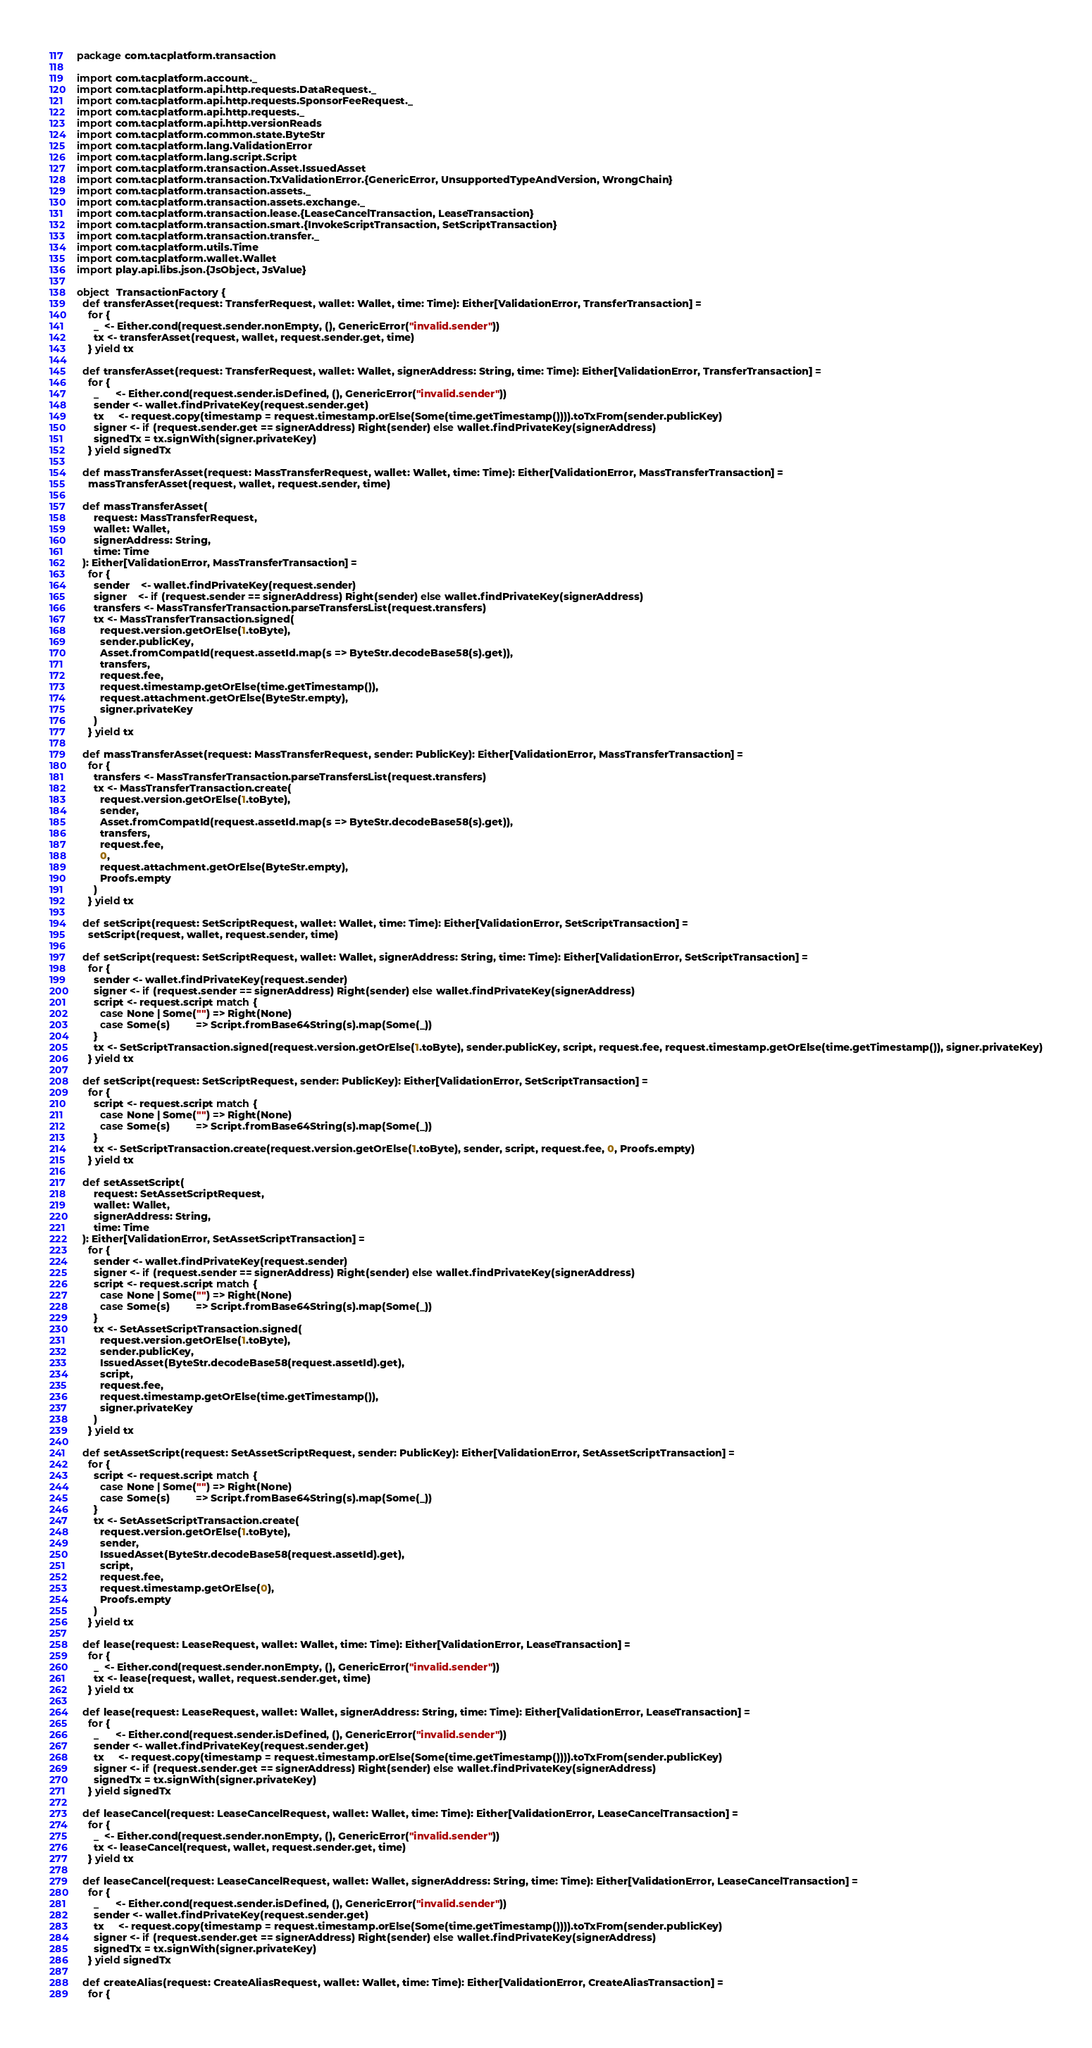Convert code to text. <code><loc_0><loc_0><loc_500><loc_500><_Scala_>package com.tacplatform.transaction

import com.tacplatform.account._
import com.tacplatform.api.http.requests.DataRequest._
import com.tacplatform.api.http.requests.SponsorFeeRequest._
import com.tacplatform.api.http.requests._
import com.tacplatform.api.http.versionReads
import com.tacplatform.common.state.ByteStr
import com.tacplatform.lang.ValidationError
import com.tacplatform.lang.script.Script
import com.tacplatform.transaction.Asset.IssuedAsset
import com.tacplatform.transaction.TxValidationError.{GenericError, UnsupportedTypeAndVersion, WrongChain}
import com.tacplatform.transaction.assets._
import com.tacplatform.transaction.assets.exchange._
import com.tacplatform.transaction.lease.{LeaseCancelTransaction, LeaseTransaction}
import com.tacplatform.transaction.smart.{InvokeScriptTransaction, SetScriptTransaction}
import com.tacplatform.transaction.transfer._
import com.tacplatform.utils.Time
import com.tacplatform.wallet.Wallet
import play.api.libs.json.{JsObject, JsValue}

object  TransactionFactory {
  def transferAsset(request: TransferRequest, wallet: Wallet, time: Time): Either[ValidationError, TransferTransaction] =
    for {
      _  <- Either.cond(request.sender.nonEmpty, (), GenericError("invalid.sender"))
      tx <- transferAsset(request, wallet, request.sender.get, time)
    } yield tx

  def transferAsset(request: TransferRequest, wallet: Wallet, signerAddress: String, time: Time): Either[ValidationError, TransferTransaction] =
    for {
      _      <- Either.cond(request.sender.isDefined, (), GenericError("invalid.sender"))
      sender <- wallet.findPrivateKey(request.sender.get)
      tx     <- request.copy(timestamp = request.timestamp.orElse(Some(time.getTimestamp()))).toTxFrom(sender.publicKey)
      signer <- if (request.sender.get == signerAddress) Right(sender) else wallet.findPrivateKey(signerAddress)
      signedTx = tx.signWith(signer.privateKey)
    } yield signedTx

  def massTransferAsset(request: MassTransferRequest, wallet: Wallet, time: Time): Either[ValidationError, MassTransferTransaction] =
    massTransferAsset(request, wallet, request.sender, time)

  def massTransferAsset(
      request: MassTransferRequest,
      wallet: Wallet,
      signerAddress: String,
      time: Time
  ): Either[ValidationError, MassTransferTransaction] =
    for {
      sender    <- wallet.findPrivateKey(request.sender)
      signer    <- if (request.sender == signerAddress) Right(sender) else wallet.findPrivateKey(signerAddress)
      transfers <- MassTransferTransaction.parseTransfersList(request.transfers)
      tx <- MassTransferTransaction.signed(
        request.version.getOrElse(1.toByte),
        sender.publicKey,
        Asset.fromCompatId(request.assetId.map(s => ByteStr.decodeBase58(s).get)),
        transfers,
        request.fee,
        request.timestamp.getOrElse(time.getTimestamp()),
        request.attachment.getOrElse(ByteStr.empty),
        signer.privateKey
      )
    } yield tx

  def massTransferAsset(request: MassTransferRequest, sender: PublicKey): Either[ValidationError, MassTransferTransaction] =
    for {
      transfers <- MassTransferTransaction.parseTransfersList(request.transfers)
      tx <- MassTransferTransaction.create(
        request.version.getOrElse(1.toByte),
        sender,
        Asset.fromCompatId(request.assetId.map(s => ByteStr.decodeBase58(s).get)),
        transfers,
        request.fee,
        0,
        request.attachment.getOrElse(ByteStr.empty),
        Proofs.empty
      )
    } yield tx

  def setScript(request: SetScriptRequest, wallet: Wallet, time: Time): Either[ValidationError, SetScriptTransaction] =
    setScript(request, wallet, request.sender, time)

  def setScript(request: SetScriptRequest, wallet: Wallet, signerAddress: String, time: Time): Either[ValidationError, SetScriptTransaction] =
    for {
      sender <- wallet.findPrivateKey(request.sender)
      signer <- if (request.sender == signerAddress) Right(sender) else wallet.findPrivateKey(signerAddress)
      script <- request.script match {
        case None | Some("") => Right(None)
        case Some(s)         => Script.fromBase64String(s).map(Some(_))
      }
      tx <- SetScriptTransaction.signed(request.version.getOrElse(1.toByte), sender.publicKey, script, request.fee, request.timestamp.getOrElse(time.getTimestamp()), signer.privateKey)
    } yield tx

  def setScript(request: SetScriptRequest, sender: PublicKey): Either[ValidationError, SetScriptTransaction] =
    for {
      script <- request.script match {
        case None | Some("") => Right(None)
        case Some(s)         => Script.fromBase64String(s).map(Some(_))
      }
      tx <- SetScriptTransaction.create(request.version.getOrElse(1.toByte), sender, script, request.fee, 0, Proofs.empty)
    } yield tx

  def setAssetScript(
      request: SetAssetScriptRequest,
      wallet: Wallet,
      signerAddress: String,
      time: Time
  ): Either[ValidationError, SetAssetScriptTransaction] =
    for {
      sender <- wallet.findPrivateKey(request.sender)
      signer <- if (request.sender == signerAddress) Right(sender) else wallet.findPrivateKey(signerAddress)
      script <- request.script match {
        case None | Some("") => Right(None)
        case Some(s)         => Script.fromBase64String(s).map(Some(_))
      }
      tx <- SetAssetScriptTransaction.signed(
        request.version.getOrElse(1.toByte),
        sender.publicKey,
        IssuedAsset(ByteStr.decodeBase58(request.assetId).get),
        script,
        request.fee,
        request.timestamp.getOrElse(time.getTimestamp()),
        signer.privateKey
      )
    } yield tx

  def setAssetScript(request: SetAssetScriptRequest, sender: PublicKey): Either[ValidationError, SetAssetScriptTransaction] =
    for {
      script <- request.script match {
        case None | Some("") => Right(None)
        case Some(s)         => Script.fromBase64String(s).map(Some(_))
      }
      tx <- SetAssetScriptTransaction.create(
        request.version.getOrElse(1.toByte),
        sender,
        IssuedAsset(ByteStr.decodeBase58(request.assetId).get),
        script,
        request.fee,
        request.timestamp.getOrElse(0),
        Proofs.empty
      )
    } yield tx

  def lease(request: LeaseRequest, wallet: Wallet, time: Time): Either[ValidationError, LeaseTransaction] =
    for {
      _  <- Either.cond(request.sender.nonEmpty, (), GenericError("invalid.sender"))
      tx <- lease(request, wallet, request.sender.get, time)
    } yield tx

  def lease(request: LeaseRequest, wallet: Wallet, signerAddress: String, time: Time): Either[ValidationError, LeaseTransaction] =
    for {
      _      <- Either.cond(request.sender.isDefined, (), GenericError("invalid.sender"))
      sender <- wallet.findPrivateKey(request.sender.get)
      tx     <- request.copy(timestamp = request.timestamp.orElse(Some(time.getTimestamp()))).toTxFrom(sender.publicKey)
      signer <- if (request.sender.get == signerAddress) Right(sender) else wallet.findPrivateKey(signerAddress)
      signedTx = tx.signWith(signer.privateKey)
    } yield signedTx

  def leaseCancel(request: LeaseCancelRequest, wallet: Wallet, time: Time): Either[ValidationError, LeaseCancelTransaction] =
    for {
      _  <- Either.cond(request.sender.nonEmpty, (), GenericError("invalid.sender"))
      tx <- leaseCancel(request, wallet, request.sender.get, time)
    } yield tx

  def leaseCancel(request: LeaseCancelRequest, wallet: Wallet, signerAddress: String, time: Time): Either[ValidationError, LeaseCancelTransaction] =
    for {
      _      <- Either.cond(request.sender.isDefined, (), GenericError("invalid.sender"))
      sender <- wallet.findPrivateKey(request.sender.get)
      tx     <- request.copy(timestamp = request.timestamp.orElse(Some(time.getTimestamp()))).toTxFrom(sender.publicKey)
      signer <- if (request.sender.get == signerAddress) Right(sender) else wallet.findPrivateKey(signerAddress)
      signedTx = tx.signWith(signer.privateKey)
    } yield signedTx

  def createAlias(request: CreateAliasRequest, wallet: Wallet, time: Time): Either[ValidationError, CreateAliasTransaction] =
    for {</code> 